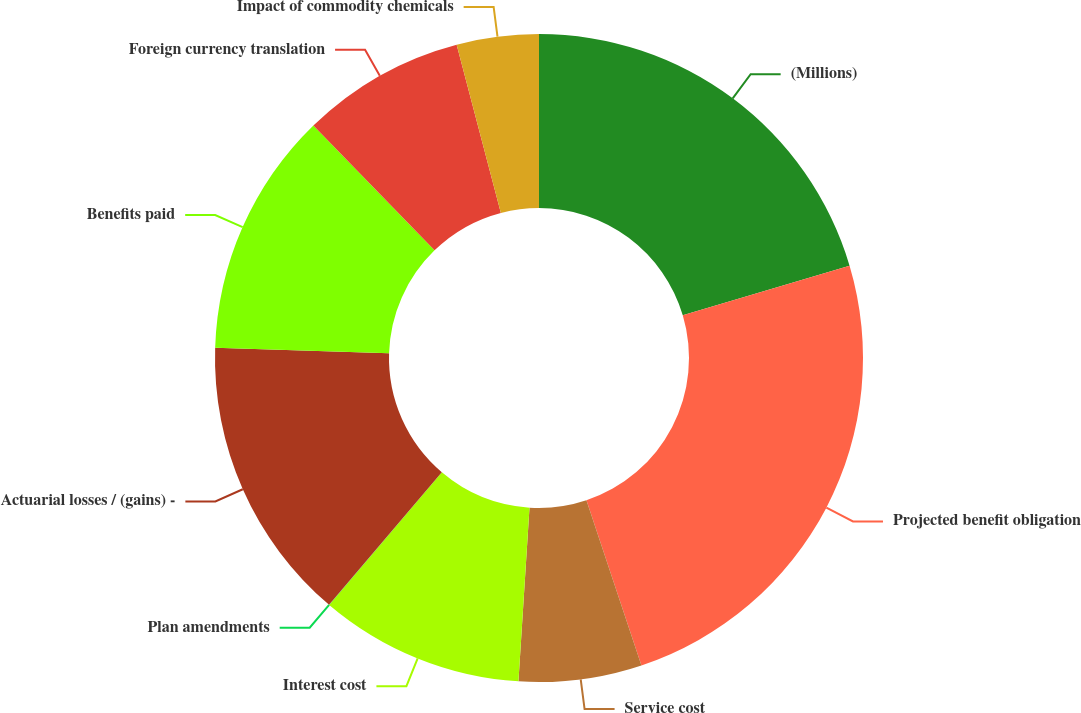Convert chart. <chart><loc_0><loc_0><loc_500><loc_500><pie_chart><fcel>(Millions)<fcel>Projected benefit obligation<fcel>Service cost<fcel>Interest cost<fcel>Plan amendments<fcel>Actuarial losses / (gains) -<fcel>Benefits paid<fcel>Foreign currency translation<fcel>Impact of commodity chemicals<nl><fcel>20.4%<fcel>24.48%<fcel>6.13%<fcel>10.2%<fcel>0.01%<fcel>14.28%<fcel>12.24%<fcel>8.17%<fcel>4.09%<nl></chart> 